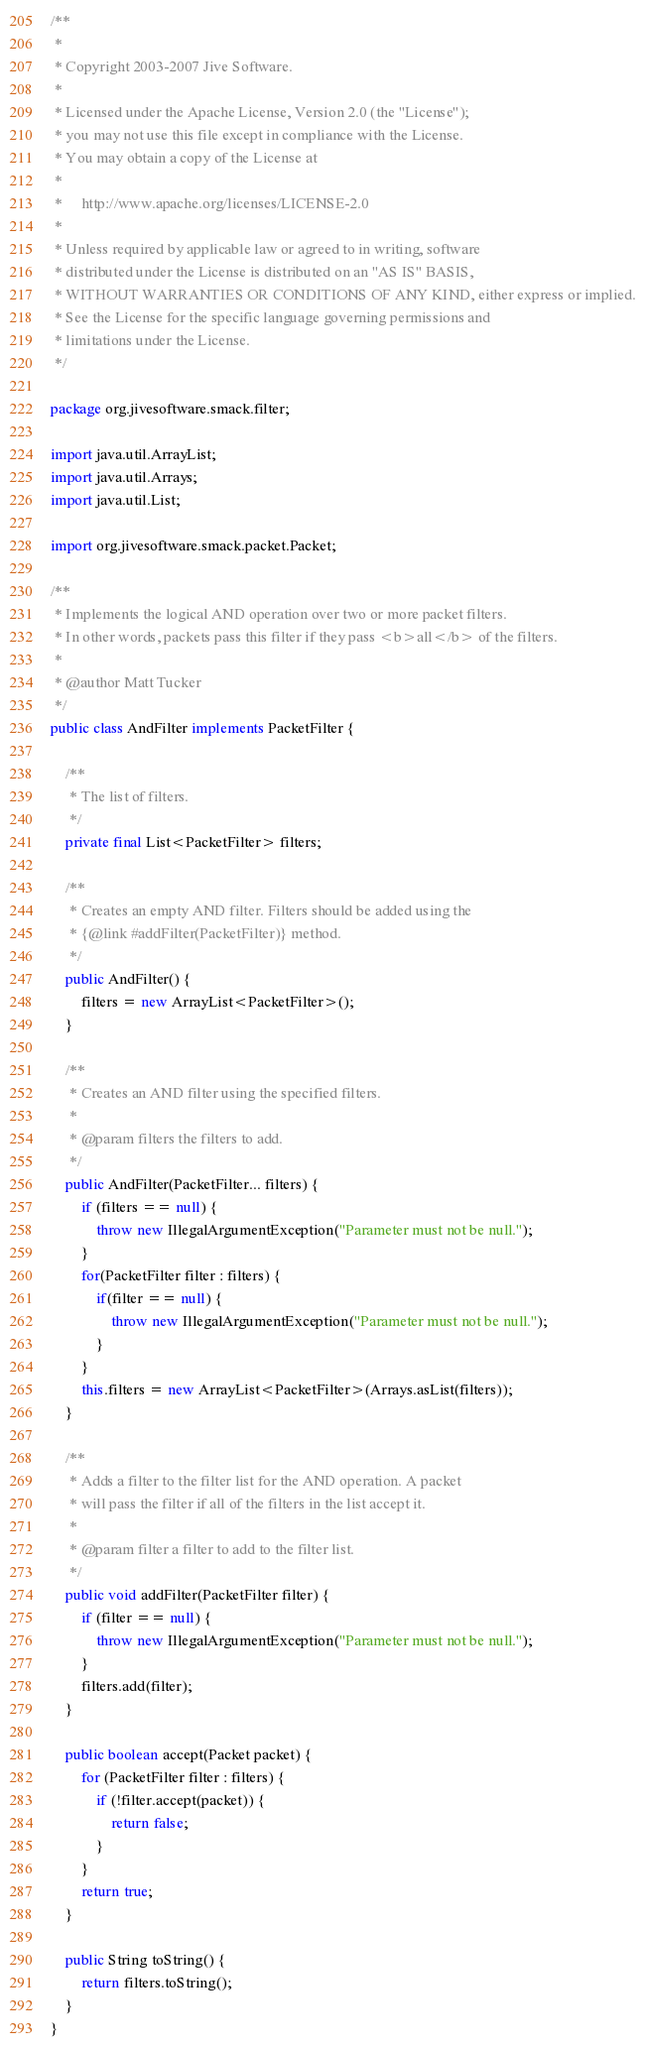Convert code to text. <code><loc_0><loc_0><loc_500><loc_500><_Java_>/**
 *
 * Copyright 2003-2007 Jive Software.
 *
 * Licensed under the Apache License, Version 2.0 (the "License");
 * you may not use this file except in compliance with the License.
 * You may obtain a copy of the License at
 *
 *     http://www.apache.org/licenses/LICENSE-2.0
 *
 * Unless required by applicable law or agreed to in writing, software
 * distributed under the License is distributed on an "AS IS" BASIS,
 * WITHOUT WARRANTIES OR CONDITIONS OF ANY KIND, either express or implied.
 * See the License for the specific language governing permissions and
 * limitations under the License.
 */

package org.jivesoftware.smack.filter;

import java.util.ArrayList;
import java.util.Arrays;
import java.util.List;

import org.jivesoftware.smack.packet.Packet;

/**
 * Implements the logical AND operation over two or more packet filters.
 * In other words, packets pass this filter if they pass <b>all</b> of the filters.
 *
 * @author Matt Tucker
 */
public class AndFilter implements PacketFilter {

    /**
     * The list of filters.
     */
    private final List<PacketFilter> filters;

    /**
     * Creates an empty AND filter. Filters should be added using the
     * {@link #addFilter(PacketFilter)} method.
     */
    public AndFilter() {
        filters = new ArrayList<PacketFilter>();
    }

    /**
     * Creates an AND filter using the specified filters.
     *
     * @param filters the filters to add.
     */
    public AndFilter(PacketFilter... filters) {
        if (filters == null) {
            throw new IllegalArgumentException("Parameter must not be null.");
        }
        for(PacketFilter filter : filters) {
            if(filter == null) {
                throw new IllegalArgumentException("Parameter must not be null.");
            }
        }
        this.filters = new ArrayList<PacketFilter>(Arrays.asList(filters));
    }

    /**
     * Adds a filter to the filter list for the AND operation. A packet
     * will pass the filter if all of the filters in the list accept it.
     *
     * @param filter a filter to add to the filter list.
     */
    public void addFilter(PacketFilter filter) {
        if (filter == null) {
            throw new IllegalArgumentException("Parameter must not be null.");
        }
        filters.add(filter);
    }

    public boolean accept(Packet packet) {
        for (PacketFilter filter : filters) {
            if (!filter.accept(packet)) {
                return false;
            }
        }
        return true;
    }

    public String toString() {
        return filters.toString();
    }
}
</code> 